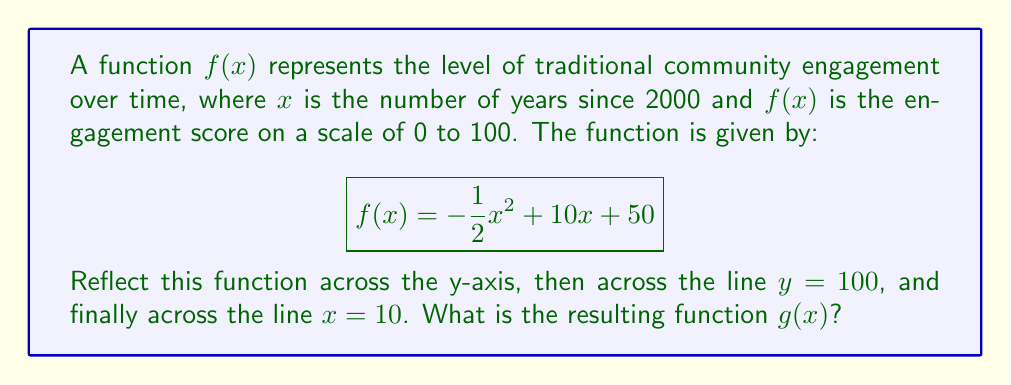Provide a solution to this math problem. Let's approach this step-by-step:

1) First, we reflect $f(x)$ across the y-axis:
   This means replacing every $x$ with $-x$:
   $$f_1(x) = -\frac{1}{2}(-x)^2 + 10(-x) + 50 = -\frac{1}{2}x^2 - 10x + 50$$

2) Next, we reflect $f_1(x)$ across the line $y = 100$:
   To do this, we subtract $f_1(x)$ from 200:
   $$f_2(x) = 200 - f_1(x) = 200 - (-\frac{1}{2}x^2 - 10x + 50) = \frac{1}{2}x^2 + 10x + 150$$

3) Finally, we reflect $f_2(x)$ across the line $x = 10$:
   This means replacing every $x$ with $(20-x)$:
   $$\begin{align*}
   g(x) &= \frac{1}{2}(20-x)^2 + 10(20-x) + 150 \\
   &= \frac{1}{2}(400-40x+x^2) + 200 - 10x + 150 \\
   &= 200 - 20x + \frac{1}{2}x^2 + 200 - 10x + 150 \\
   &= \frac{1}{2}x^2 - 30x + 550
   \end{align*}$$

Therefore, the resulting function $g(x)$ is $\frac{1}{2}x^2 - 30x + 550$.
Answer: $$g(x) = \frac{1}{2}x^2 - 30x + 550$$ 